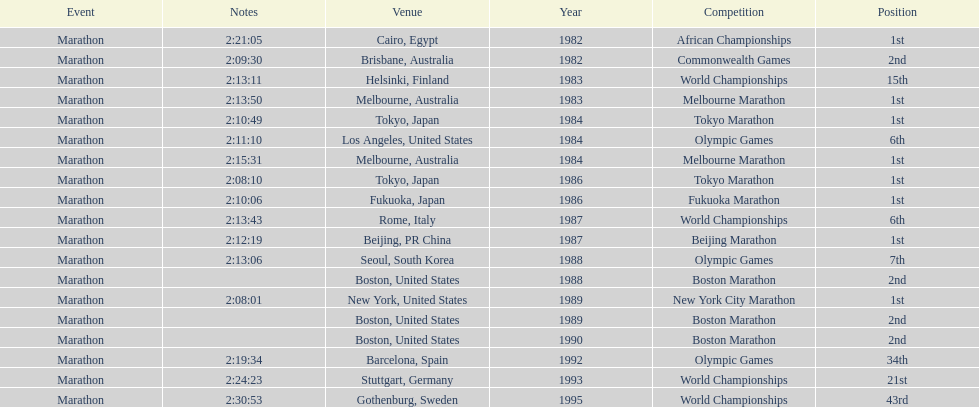What was the first marathon juma ikangaa won? 1982 African Championships. 